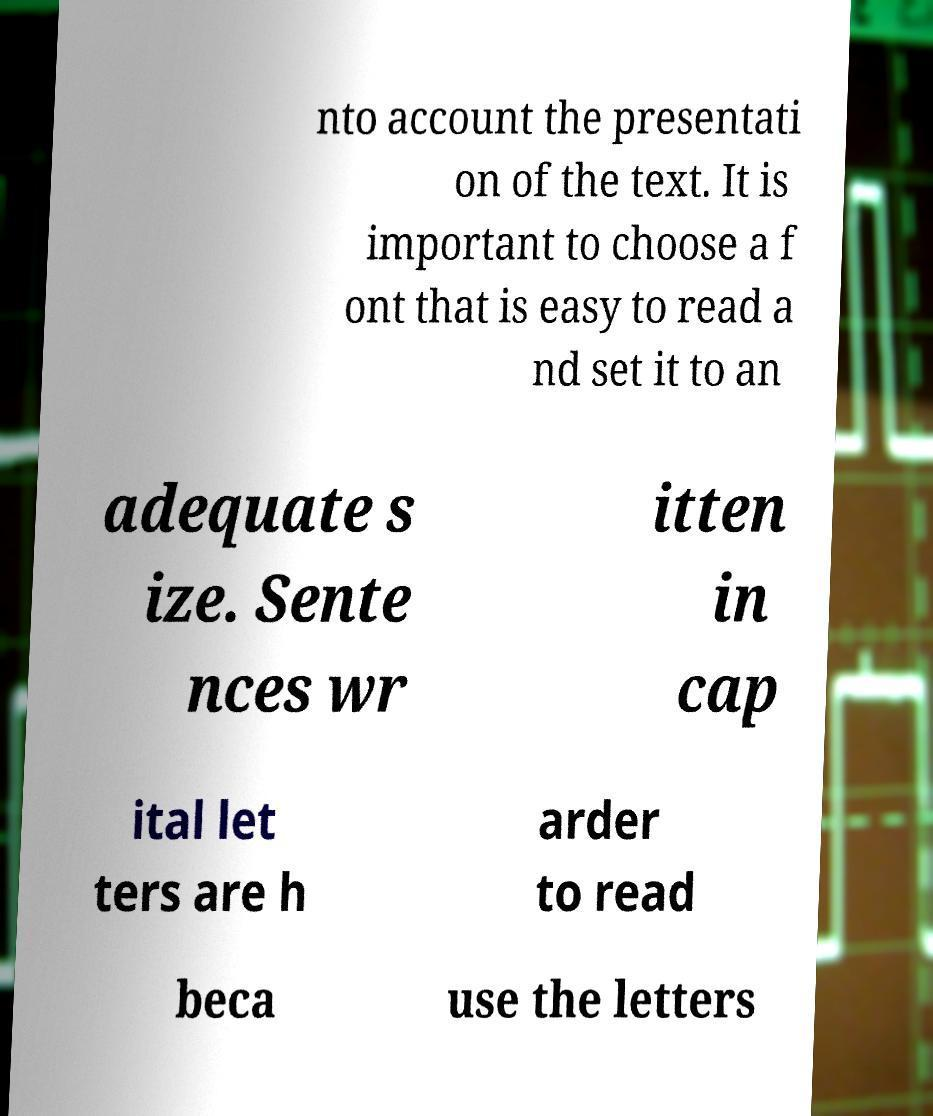I need the written content from this picture converted into text. Can you do that? nto account the presentati on of the text. It is important to choose a f ont that is easy to read a nd set it to an adequate s ize. Sente nces wr itten in cap ital let ters are h arder to read beca use the letters 